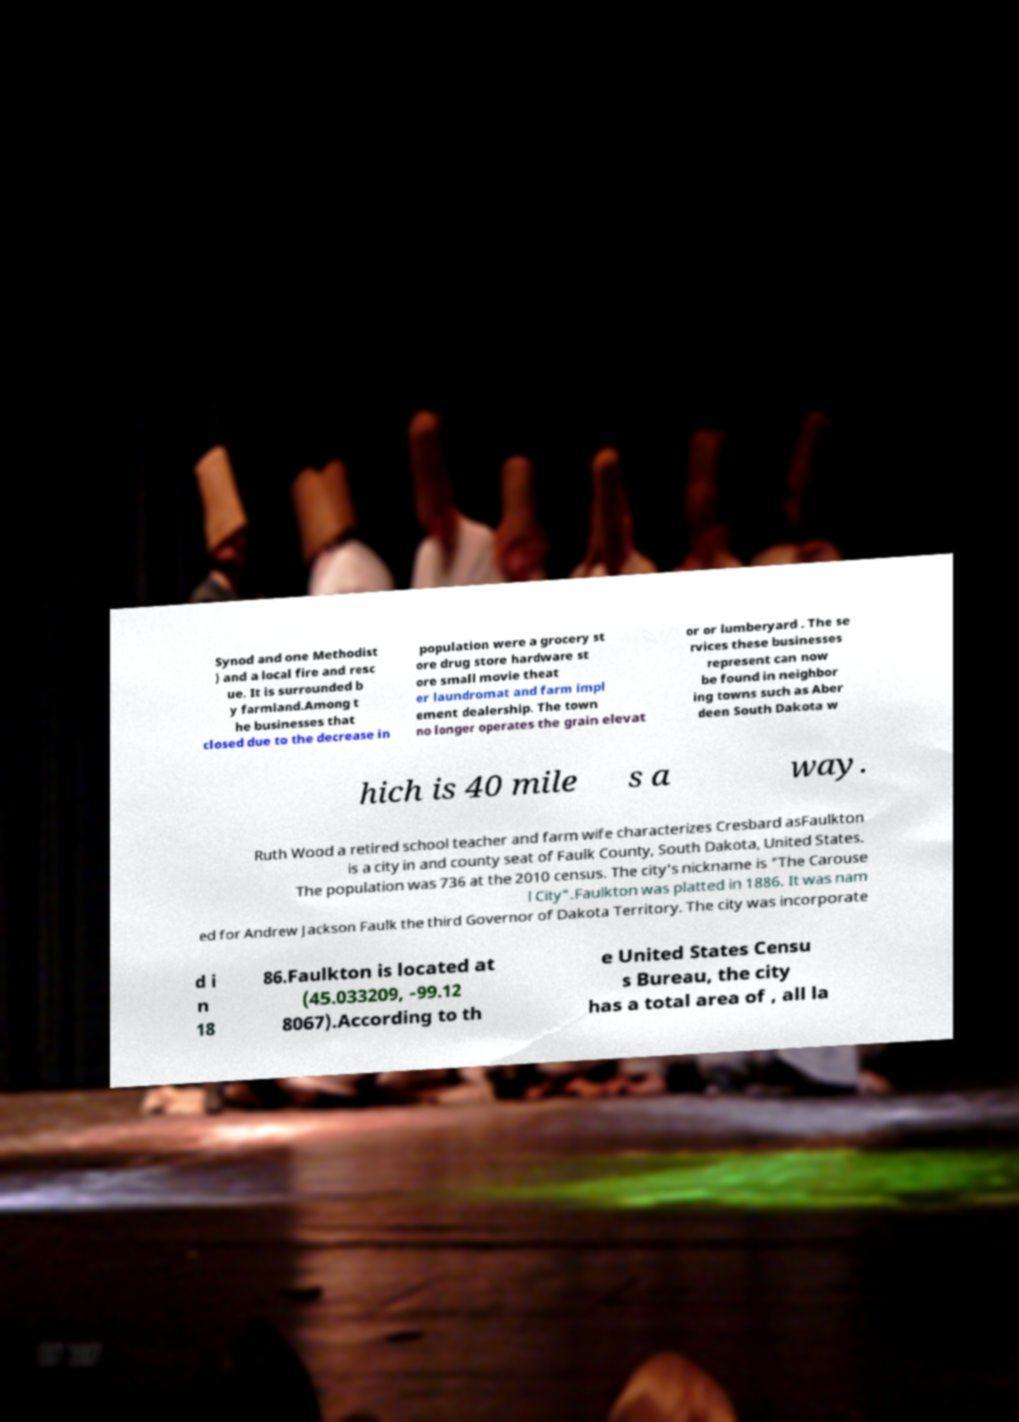Can you read and provide the text displayed in the image?This photo seems to have some interesting text. Can you extract and type it out for me? Synod and one Methodist ) and a local fire and resc ue. It is surrounded b y farmland.Among t he businesses that closed due to the decrease in population were a grocery st ore drug store hardware st ore small movie theat er laundromat and farm impl ement dealership. The town no longer operates the grain elevat or or lumberyard . The se rvices these businesses represent can now be found in neighbor ing towns such as Aber deen South Dakota w hich is 40 mile s a way. Ruth Wood a retired school teacher and farm wife characterizes Cresbard asFaulkton is a city in and county seat of Faulk County, South Dakota, United States. The population was 736 at the 2010 census. The city's nickname is "The Carouse l City".Faulkton was platted in 1886. It was nam ed for Andrew Jackson Faulk the third Governor of Dakota Territory. The city was incorporate d i n 18 86.Faulkton is located at (45.033209, -99.12 8067).According to th e United States Censu s Bureau, the city has a total area of , all la 